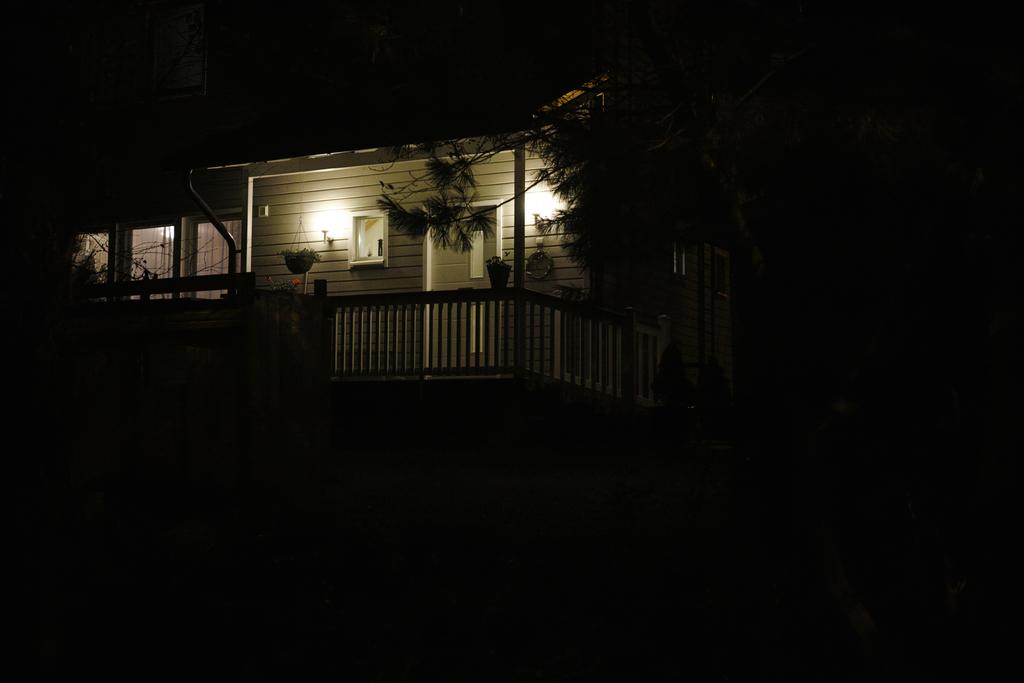What structure is visible in the image? There is a roof in the image. What feature is present on the roof? The roof has a fence. What can be seen through the fence? The image contains windows. What type of vegetation is present in the image? There are plants in pots and a tree visible in the image. What color is the marble used for the chalk in the image? There is no marble or chalk present in the image. How many horses are visible in the image? There are no horses visible in the image. 